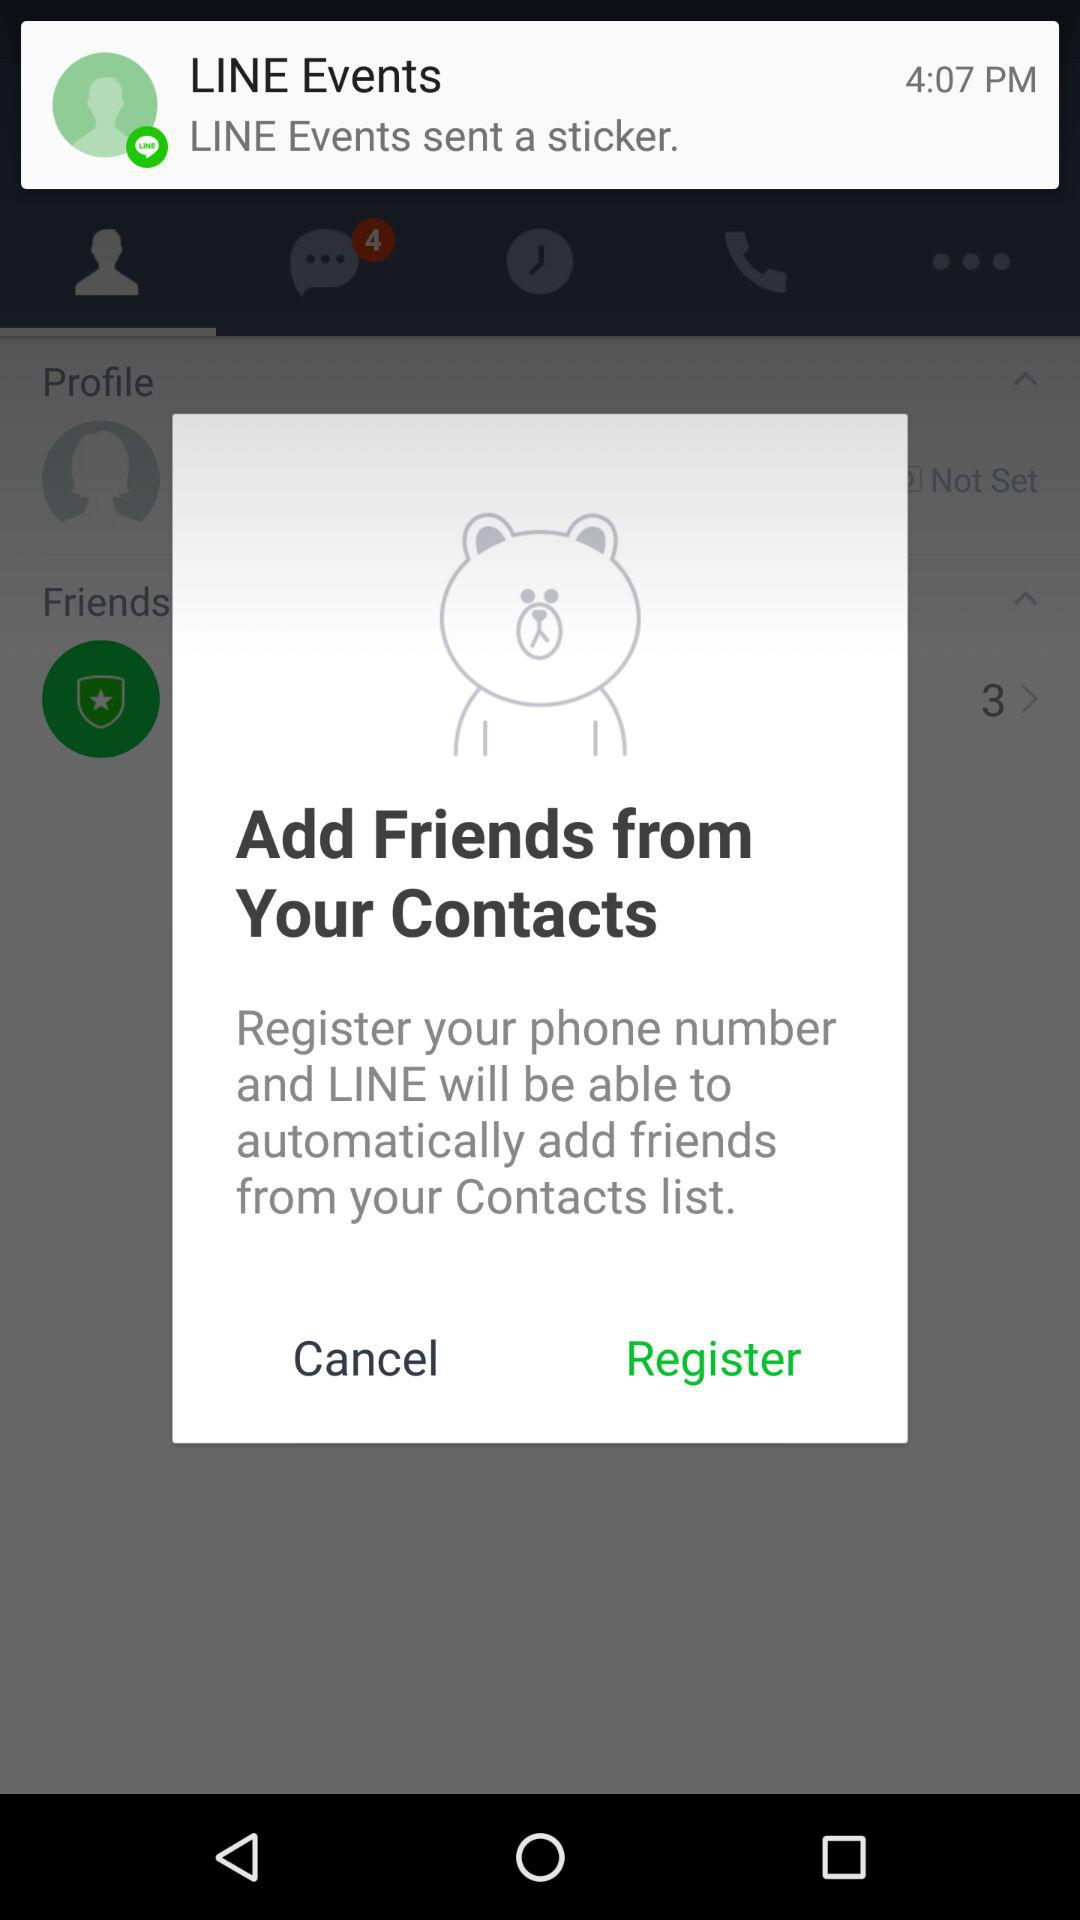Is the phone number registered?
When the provided information is insufficient, respond with <no answer>. <no answer> 